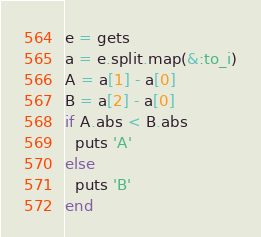<code> <loc_0><loc_0><loc_500><loc_500><_Ruby_>e = gets
a = e.split.map(&:to_i)
A = a[1] - a[0]
B = a[2] - a[0]
if A.abs < B.abs
  puts 'A'
else
  puts 'B'
end
</code> 